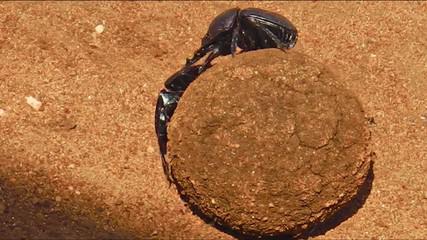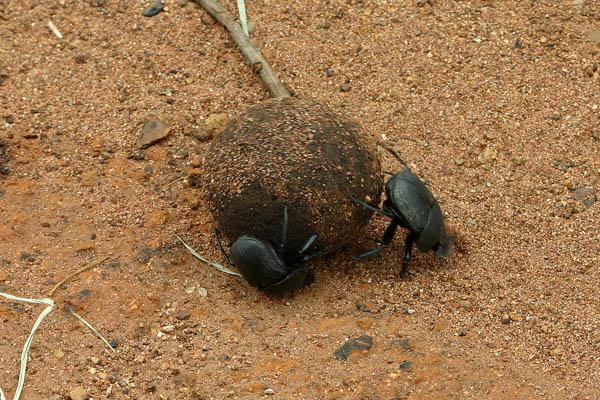The first image is the image on the left, the second image is the image on the right. Considering the images on both sides, is "Each image includes at least one beetle in contact with a brown ball." valid? Answer yes or no. Yes. The first image is the image on the left, the second image is the image on the right. Assess this claim about the two images: "One of the dung beetles is not near a ball of dung.". Correct or not? Answer yes or no. No. 